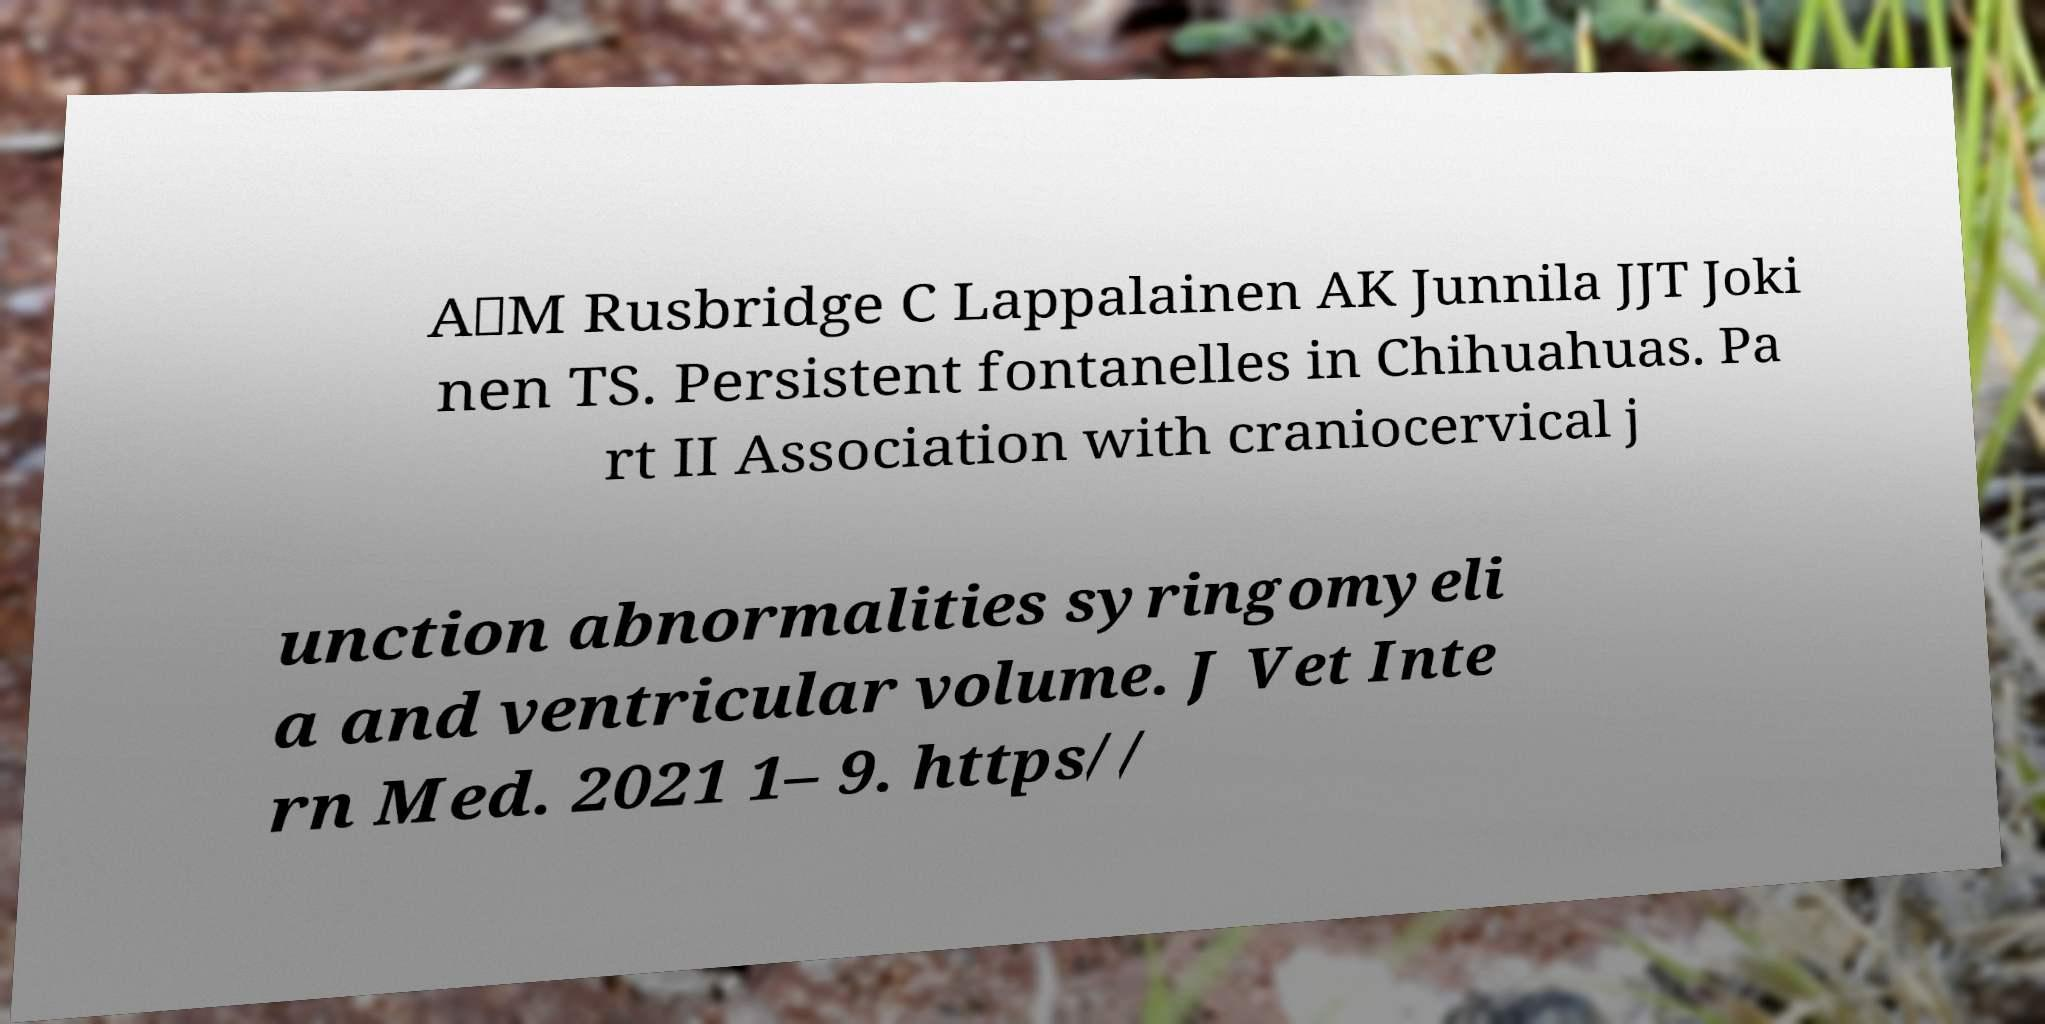Can you accurately transcribe the text from the provided image for me? A‐M Rusbridge C Lappalainen AK Junnila JJT Joki nen TS. Persistent fontanelles in Chihuahuas. Pa rt II Association with craniocervical j unction abnormalities syringomyeli a and ventricular volume. J Vet Inte rn Med. 2021 1– 9. https// 